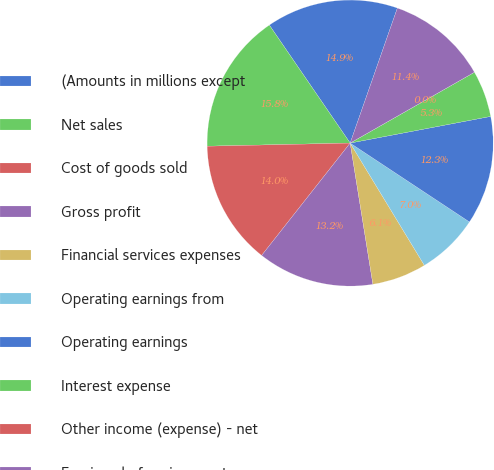Convert chart. <chart><loc_0><loc_0><loc_500><loc_500><pie_chart><fcel>(Amounts in millions except<fcel>Net sales<fcel>Cost of goods sold<fcel>Gross profit<fcel>Financial services expenses<fcel>Operating earnings from<fcel>Operating earnings<fcel>Interest expense<fcel>Other income (expense) - net<fcel>Earnings before income taxes<nl><fcel>14.91%<fcel>15.79%<fcel>14.03%<fcel>13.16%<fcel>6.14%<fcel>7.02%<fcel>12.28%<fcel>5.26%<fcel>0.0%<fcel>11.4%<nl></chart> 